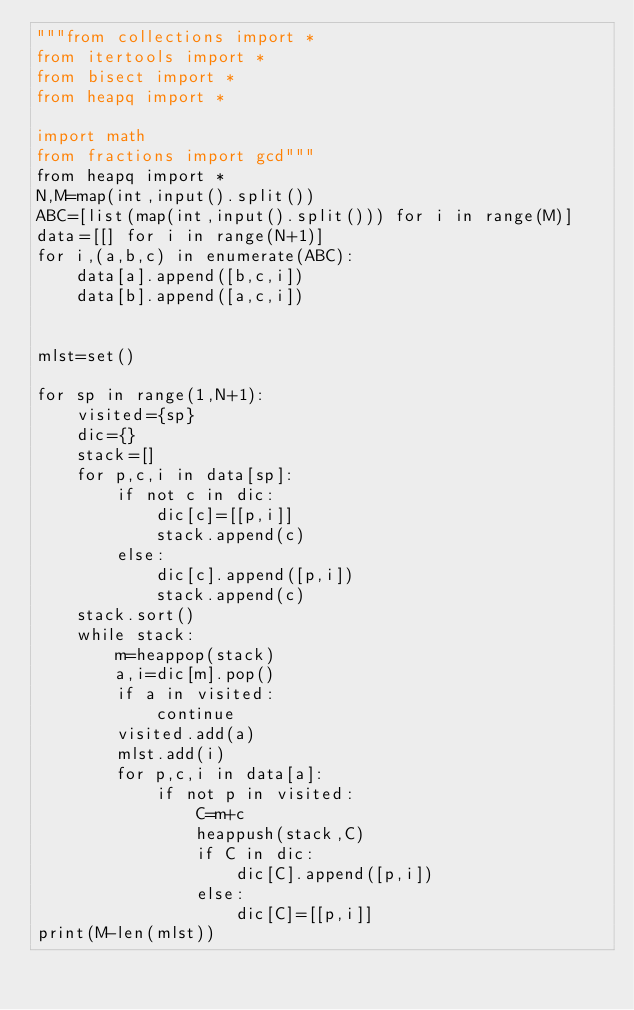Convert code to text. <code><loc_0><loc_0><loc_500><loc_500><_Python_>"""from collections import *
from itertools import *
from bisect import *
from heapq import *

import math
from fractions import gcd"""
from heapq import *
N,M=map(int,input().split())
ABC=[list(map(int,input().split())) for i in range(M)]
data=[[] for i in range(N+1)]
for i,(a,b,c) in enumerate(ABC):
    data[a].append([b,c,i])
    data[b].append([a,c,i])


mlst=set()

for sp in range(1,N+1):
    visited={sp}
    dic={}
    stack=[]
    for p,c,i in data[sp]:
        if not c in dic:
            dic[c]=[[p,i]]
            stack.append(c)
        else:
            dic[c].append([p,i])
            stack.append(c)
    stack.sort()
    while stack:
        m=heappop(stack)
        a,i=dic[m].pop()
        if a in visited:
            continue
        visited.add(a)
        mlst.add(i)
        for p,c,i in data[a]:
            if not p in visited:
                C=m+c
                heappush(stack,C)
                if C in dic:
                    dic[C].append([p,i])
                else:
                    dic[C]=[[p,i]]
print(M-len(mlst))
</code> 